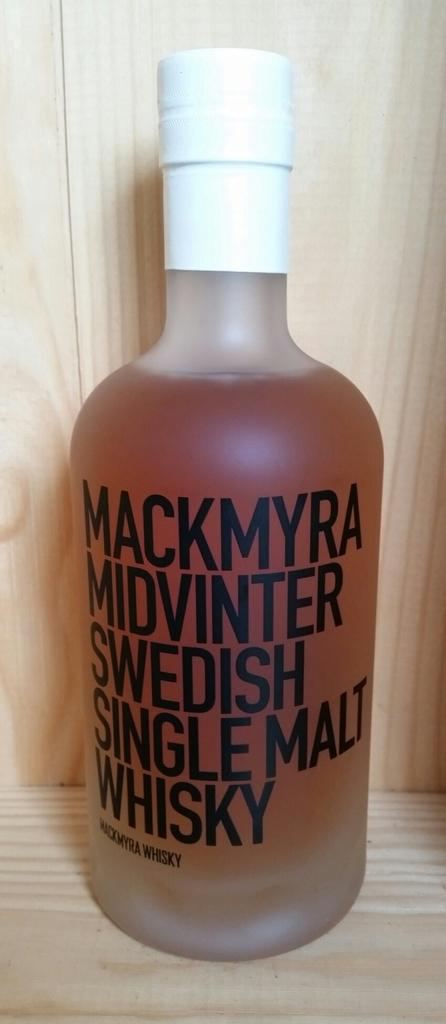Provide a one-sentence caption for the provided image. A medium sized frosted glass bottle contains single malt whisky. 